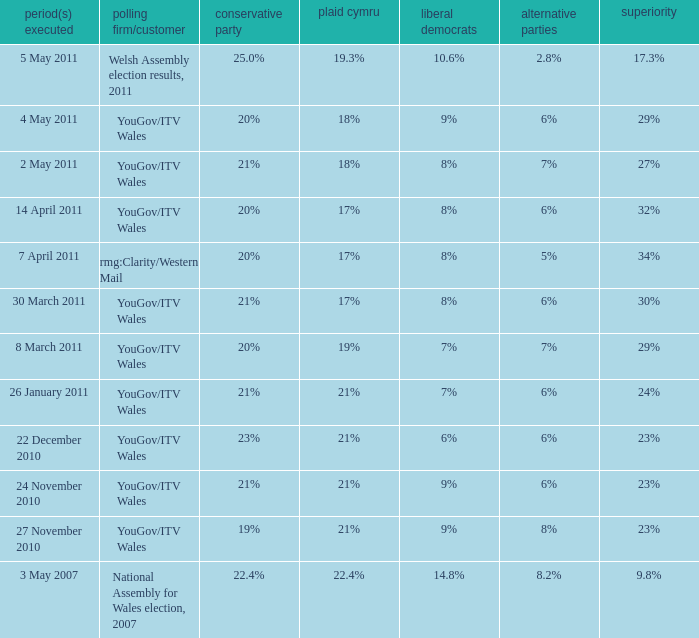Name the others for cons of 21% and lead of 24% 6%. 